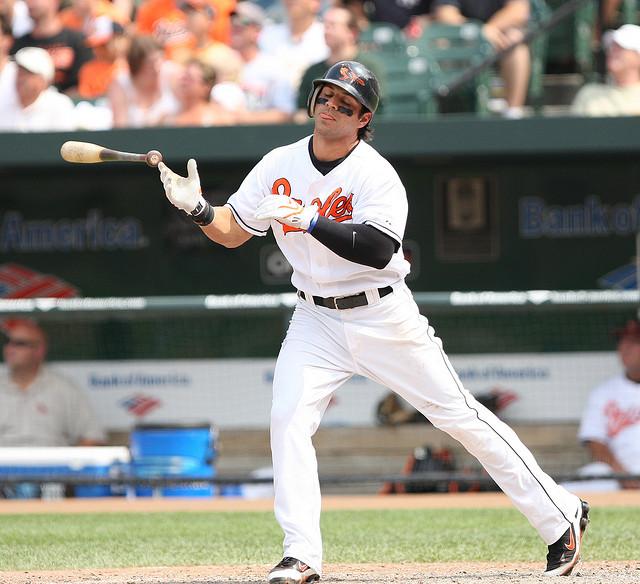The area where the people are sitting in the audience is commonly known as what?
Write a very short answer. Stands. What sport is the man participating in?
Quick response, please. Baseball. What color is his jersey?
Give a very brief answer. White. 